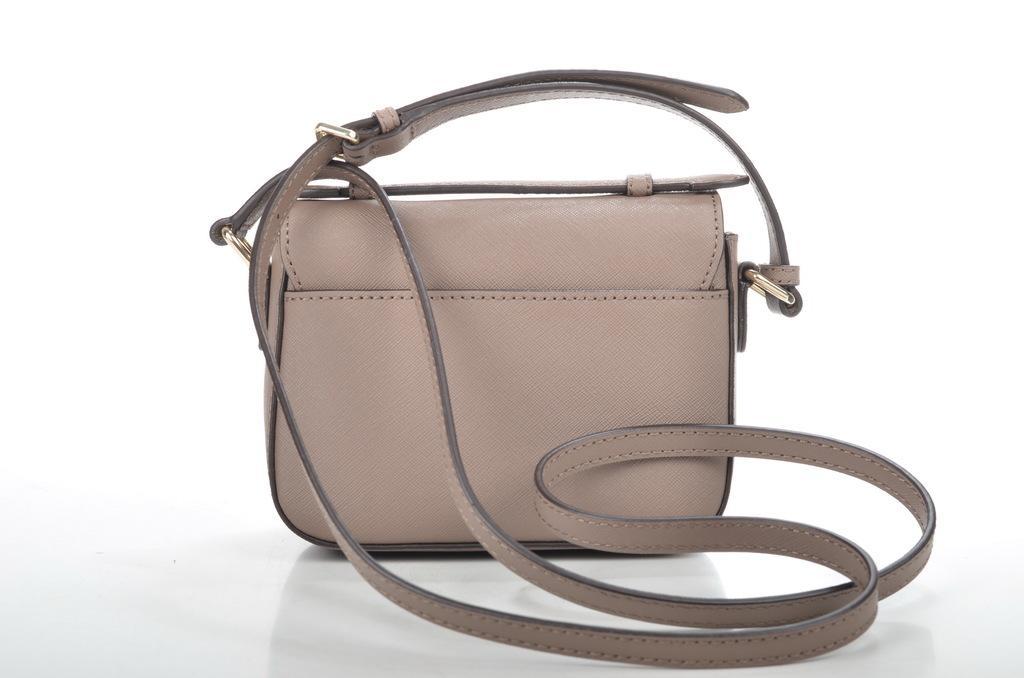How would you summarize this image in a sentence or two? In this picture there is a handbag with leather on it and holder 